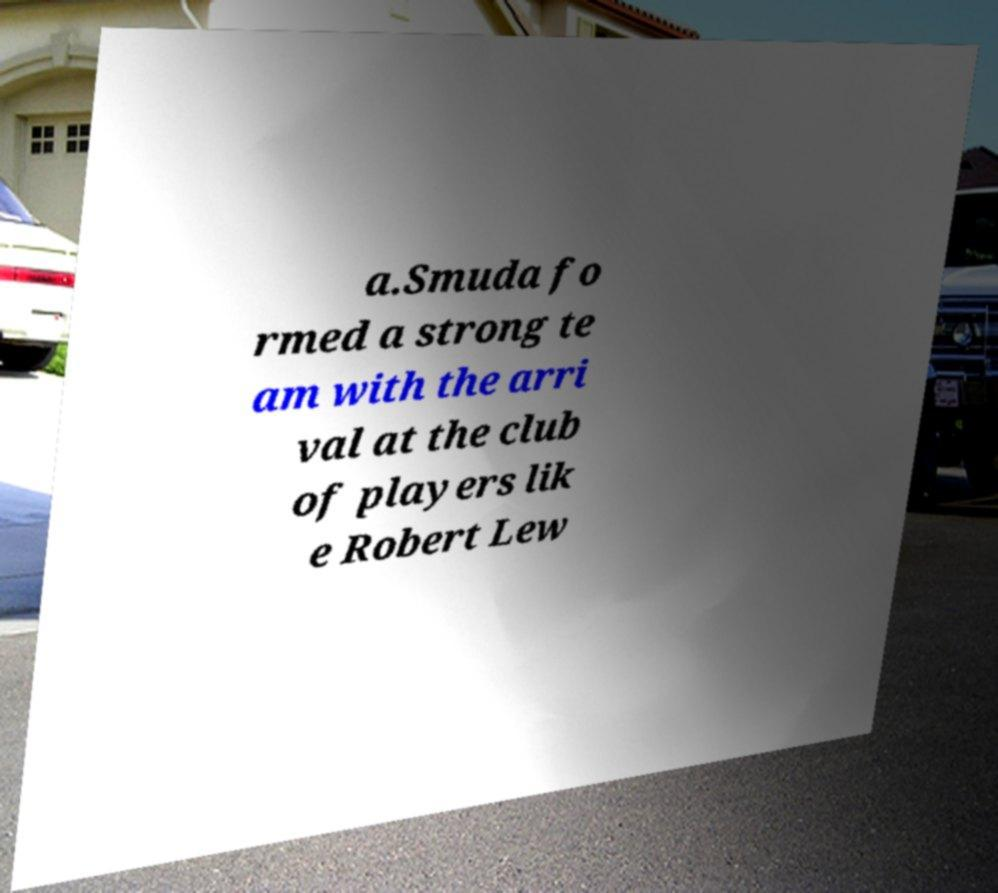Please read and relay the text visible in this image. What does it say? a.Smuda fo rmed a strong te am with the arri val at the club of players lik e Robert Lew 